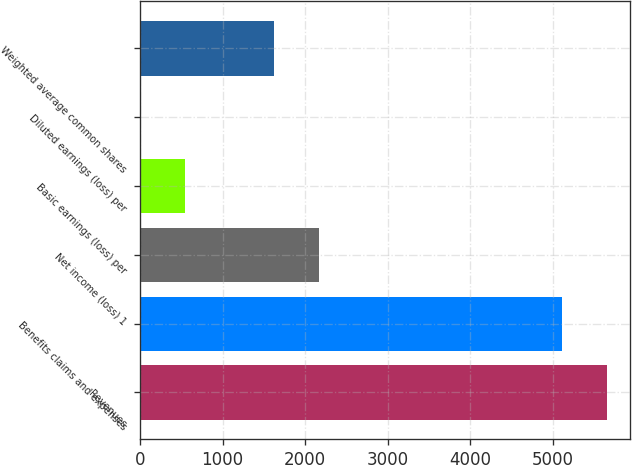Convert chart to OTSL. <chart><loc_0><loc_0><loc_500><loc_500><bar_chart><fcel>Revenues<fcel>Benefits claims and expenses<fcel>Net income (loss) 1<fcel>Basic earnings (loss) per<fcel>Diluted earnings (loss) per<fcel>Weighted average common shares<nl><fcel>5650.43<fcel>5109<fcel>2167.38<fcel>543.09<fcel>1.66<fcel>1625.95<nl></chart> 